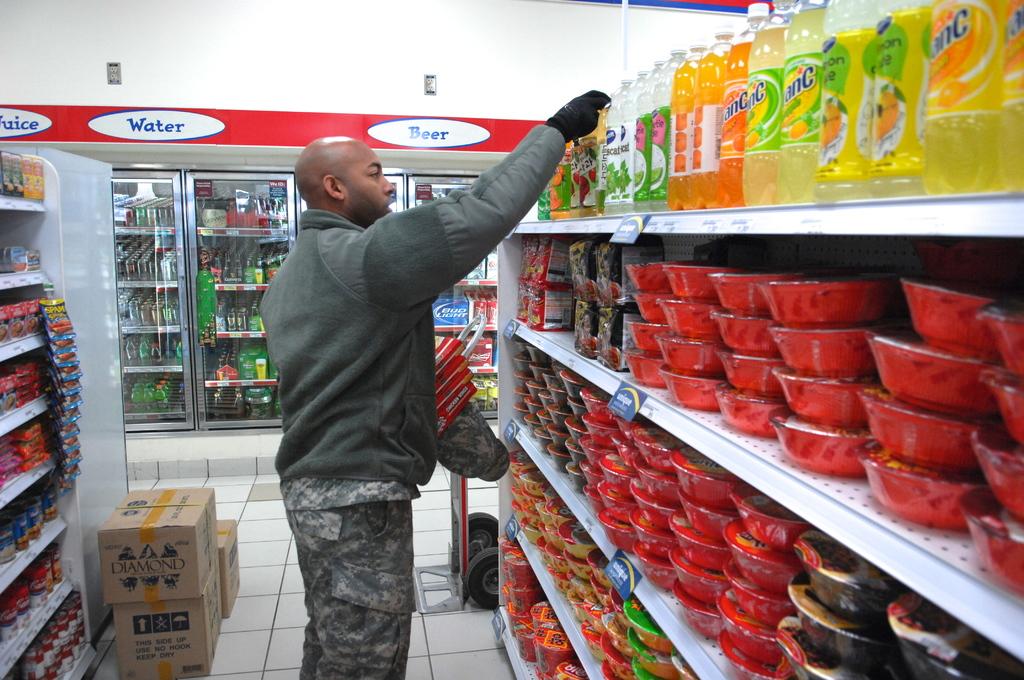What brand is on the box?
Offer a very short reply. Diamond. 